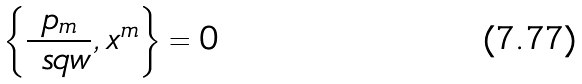<formula> <loc_0><loc_0><loc_500><loc_500>\left \{ \frac { p _ { m } } { \ s q w } , x ^ { m } \right \} = 0</formula> 